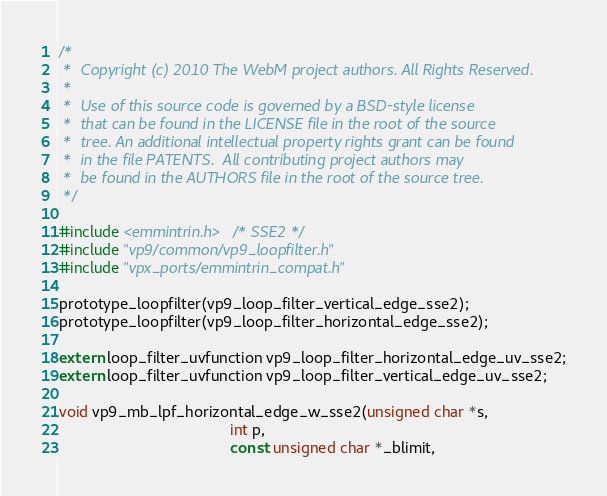Convert code to text. <code><loc_0><loc_0><loc_500><loc_500><_C_>/*
 *  Copyright (c) 2010 The WebM project authors. All Rights Reserved.
 *
 *  Use of this source code is governed by a BSD-style license
 *  that can be found in the LICENSE file in the root of the source
 *  tree. An additional intellectual property rights grant can be found
 *  in the file PATENTS.  All contributing project authors may
 *  be found in the AUTHORS file in the root of the source tree.
 */

#include <emmintrin.h>  /* SSE2 */
#include "vp9/common/vp9_loopfilter.h"
#include "vpx_ports/emmintrin_compat.h"

prototype_loopfilter(vp9_loop_filter_vertical_edge_sse2);
prototype_loopfilter(vp9_loop_filter_horizontal_edge_sse2);

extern loop_filter_uvfunction vp9_loop_filter_horizontal_edge_uv_sse2;
extern loop_filter_uvfunction vp9_loop_filter_vertical_edge_uv_sse2;

void vp9_mb_lpf_horizontal_edge_w_sse2(unsigned char *s,
                                       int p,
                                       const unsigned char *_blimit,</code> 